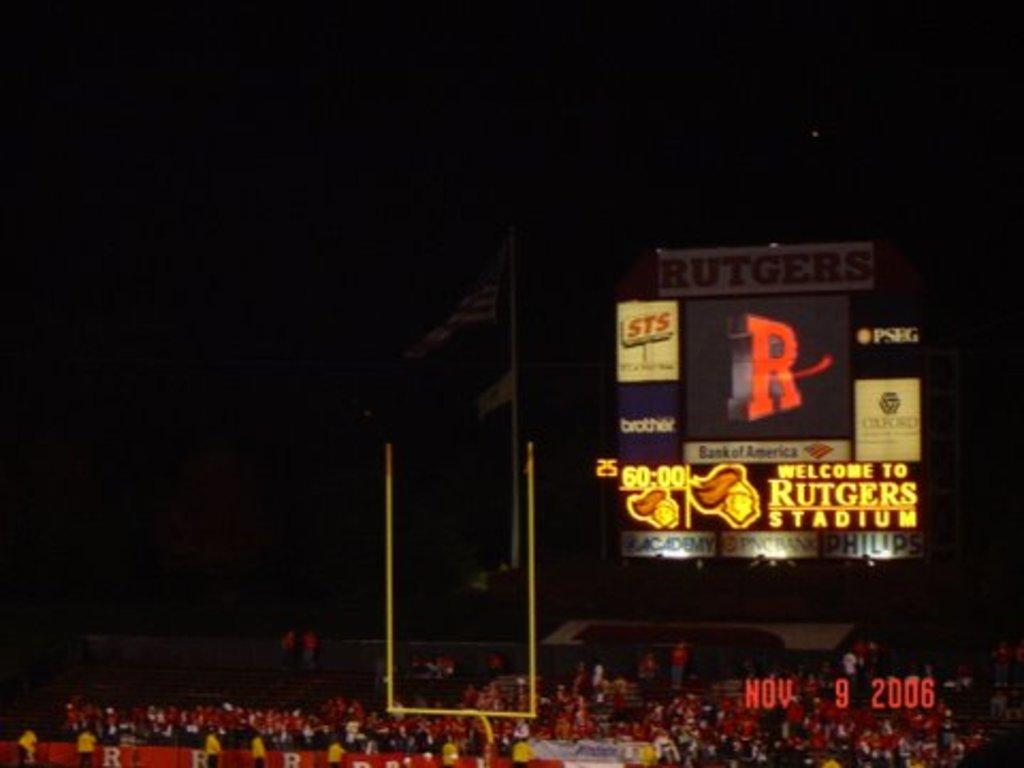<image>
Relay a brief, clear account of the picture shown. The Rutgers playing football at their home stadium 